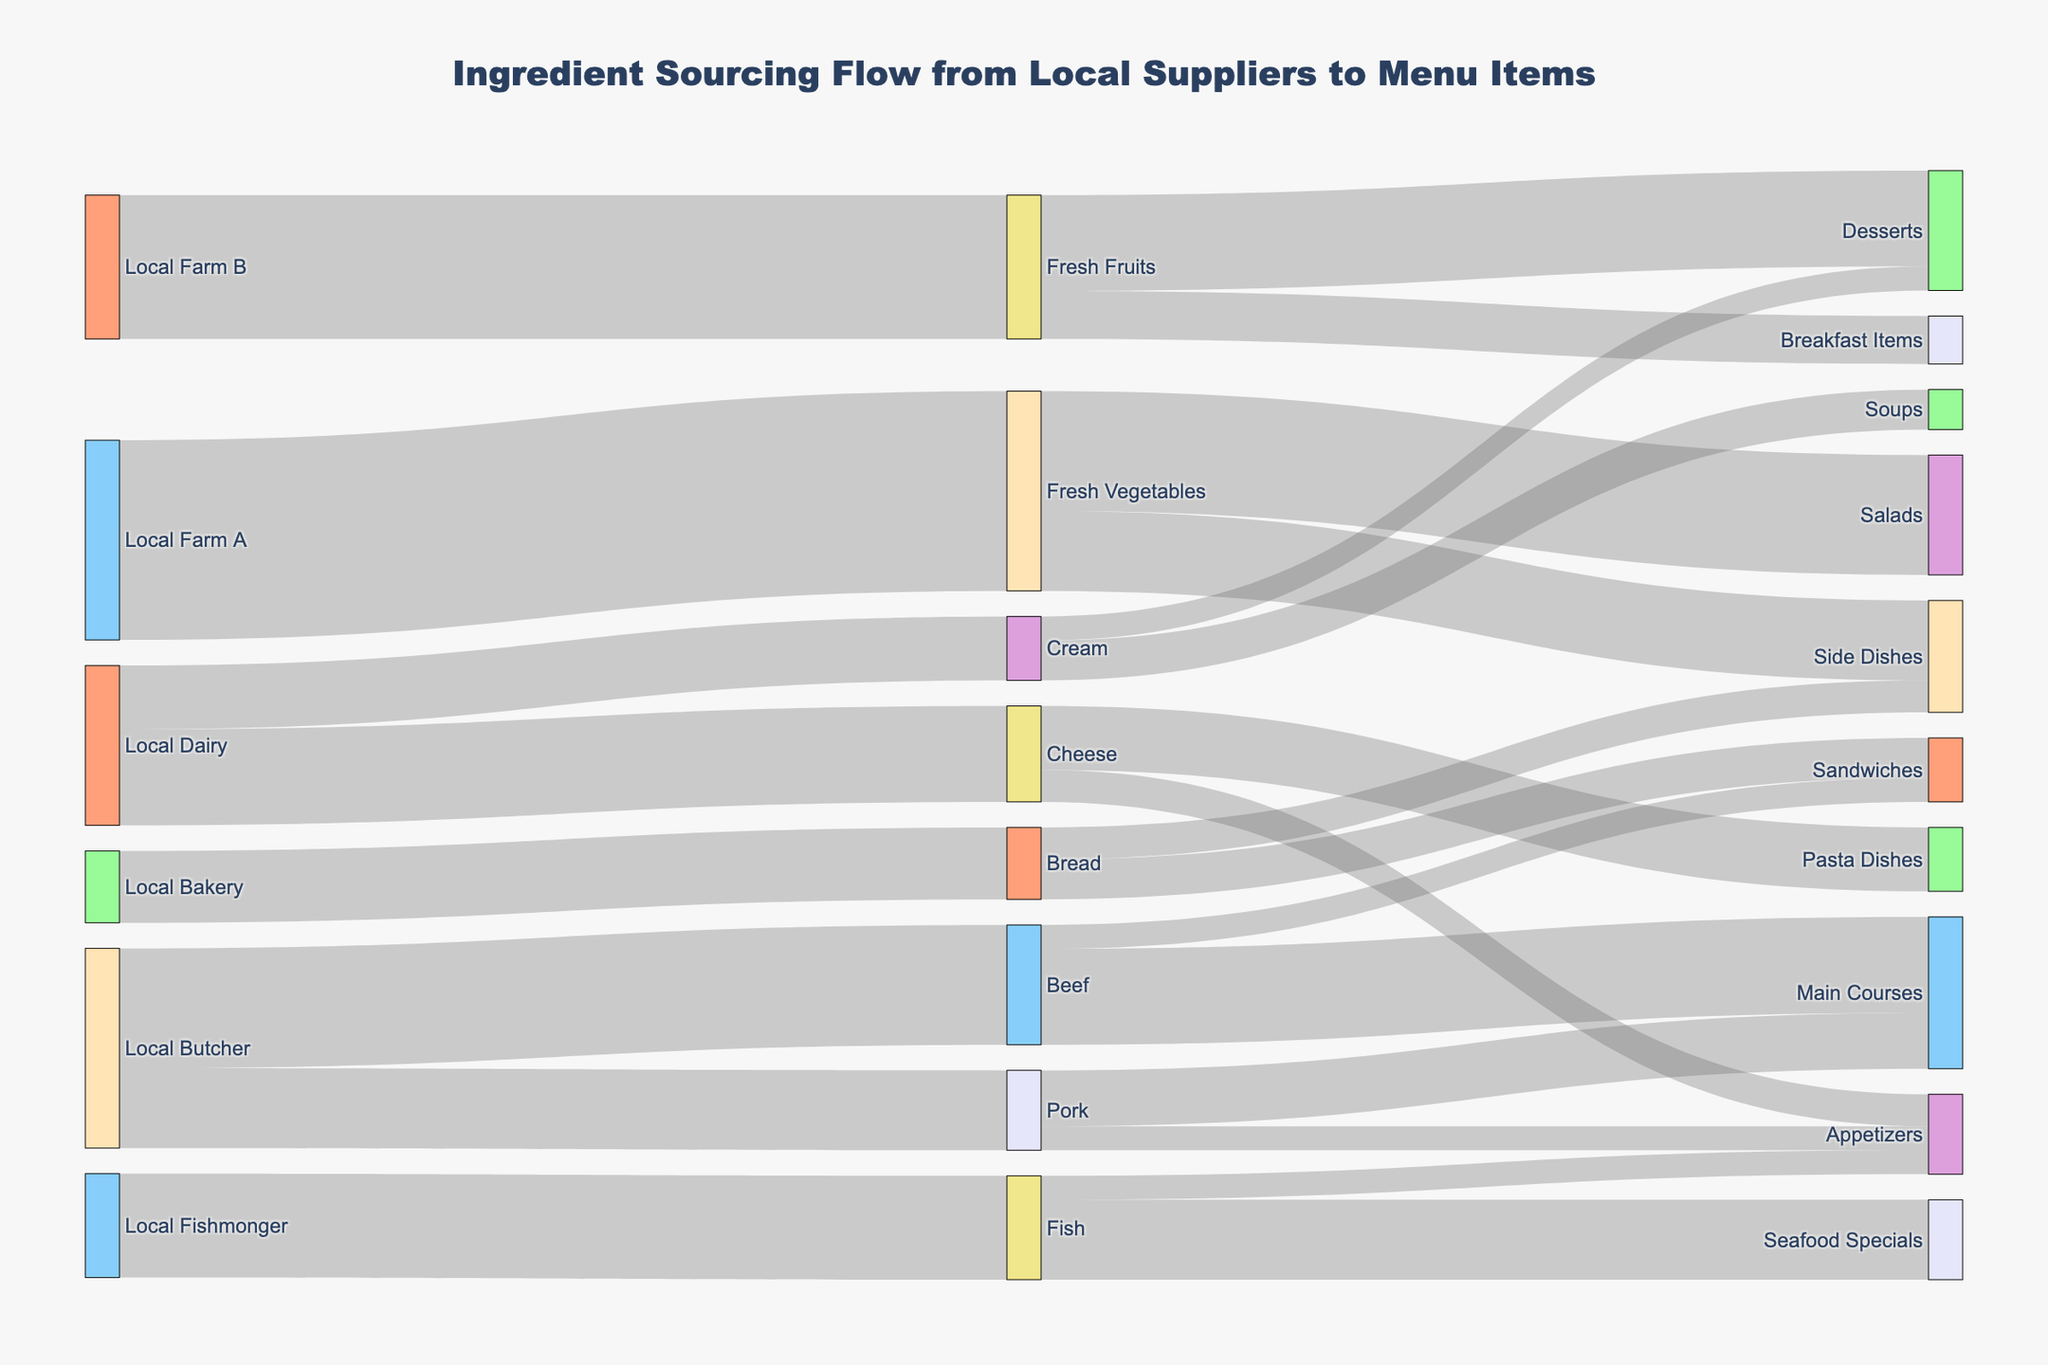What's the title of the diagram? The title is written at the top of the figure, which summarizes the content. In this case, it reads "Ingredient Sourcing Flow from Local Suppliers to Menu Items."
Answer: Ingredient Sourcing Flow from Local Suppliers to Menu Items Which supplier provides the most ingredients by value? By comparing the sum of the values of all links originating from each supplier, we can identify the supplier with the highest total value.
Answer: Local Farm A Which menu item receives the highest value of ingredients from suppliers? By summing the values of the links pointing to each menu item, the menu item with the highest value can be identified as Salads with a total of 1500 from Fresh Vegetables.
Answer: Salads How much Fresh Vegetables are sourced from Local Farm A? The value of the link from Local Farm A to Fresh Vegetables gives the total amount sourced. In this case, it's 2500.
Answer: 2500 How much total ingredient value does the Local Dairy supply? Adding up the values of the links from Local Dairy to Cheese and Cream gives the total value (1200 for Cheese + 800 for Cream).
Answer: 2000 What proportion of Fresh Vegetables goes to Salads? The value of Fresh Vegetables going to Salads is 1500. Out of the total 2500 sourced from Local Farm A, this proportion is calculated by 1500/2500 * 100.
Answer: 60% What is the difference in value between Beef and Pork supplied to Main Courses? The values for Beef and Pork to Main Courses are 1200 and 700 respectively. The difference is calculated as 1200 - 700.
Answer: 500 Which supplier is more diversified in their offerings in terms of types of ingredients? Checking the number of different types of ingredients supplied by each supplier reveals that Local Dairy offers both Cheese and Cream.
Answer: Local Dairy Which source supplies ingredients for the most diverse range of menu items? By counting the number of menu items each ingredient is linked to, Fresh Vegetables supply ingredients for both Salads (1500) and Side Dishes (1000).
Answer: Fresh Vegetables From which supplier does Bread come, and what menu items does it contribute to? Bread is sourced from Local Bakery and goes to Sandwiches (500) and Side Dishes (400).
Answer: Local Bakery, Sandwiches and Side Dishes 